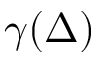<formula> <loc_0><loc_0><loc_500><loc_500>\gamma ( \Delta )</formula> 